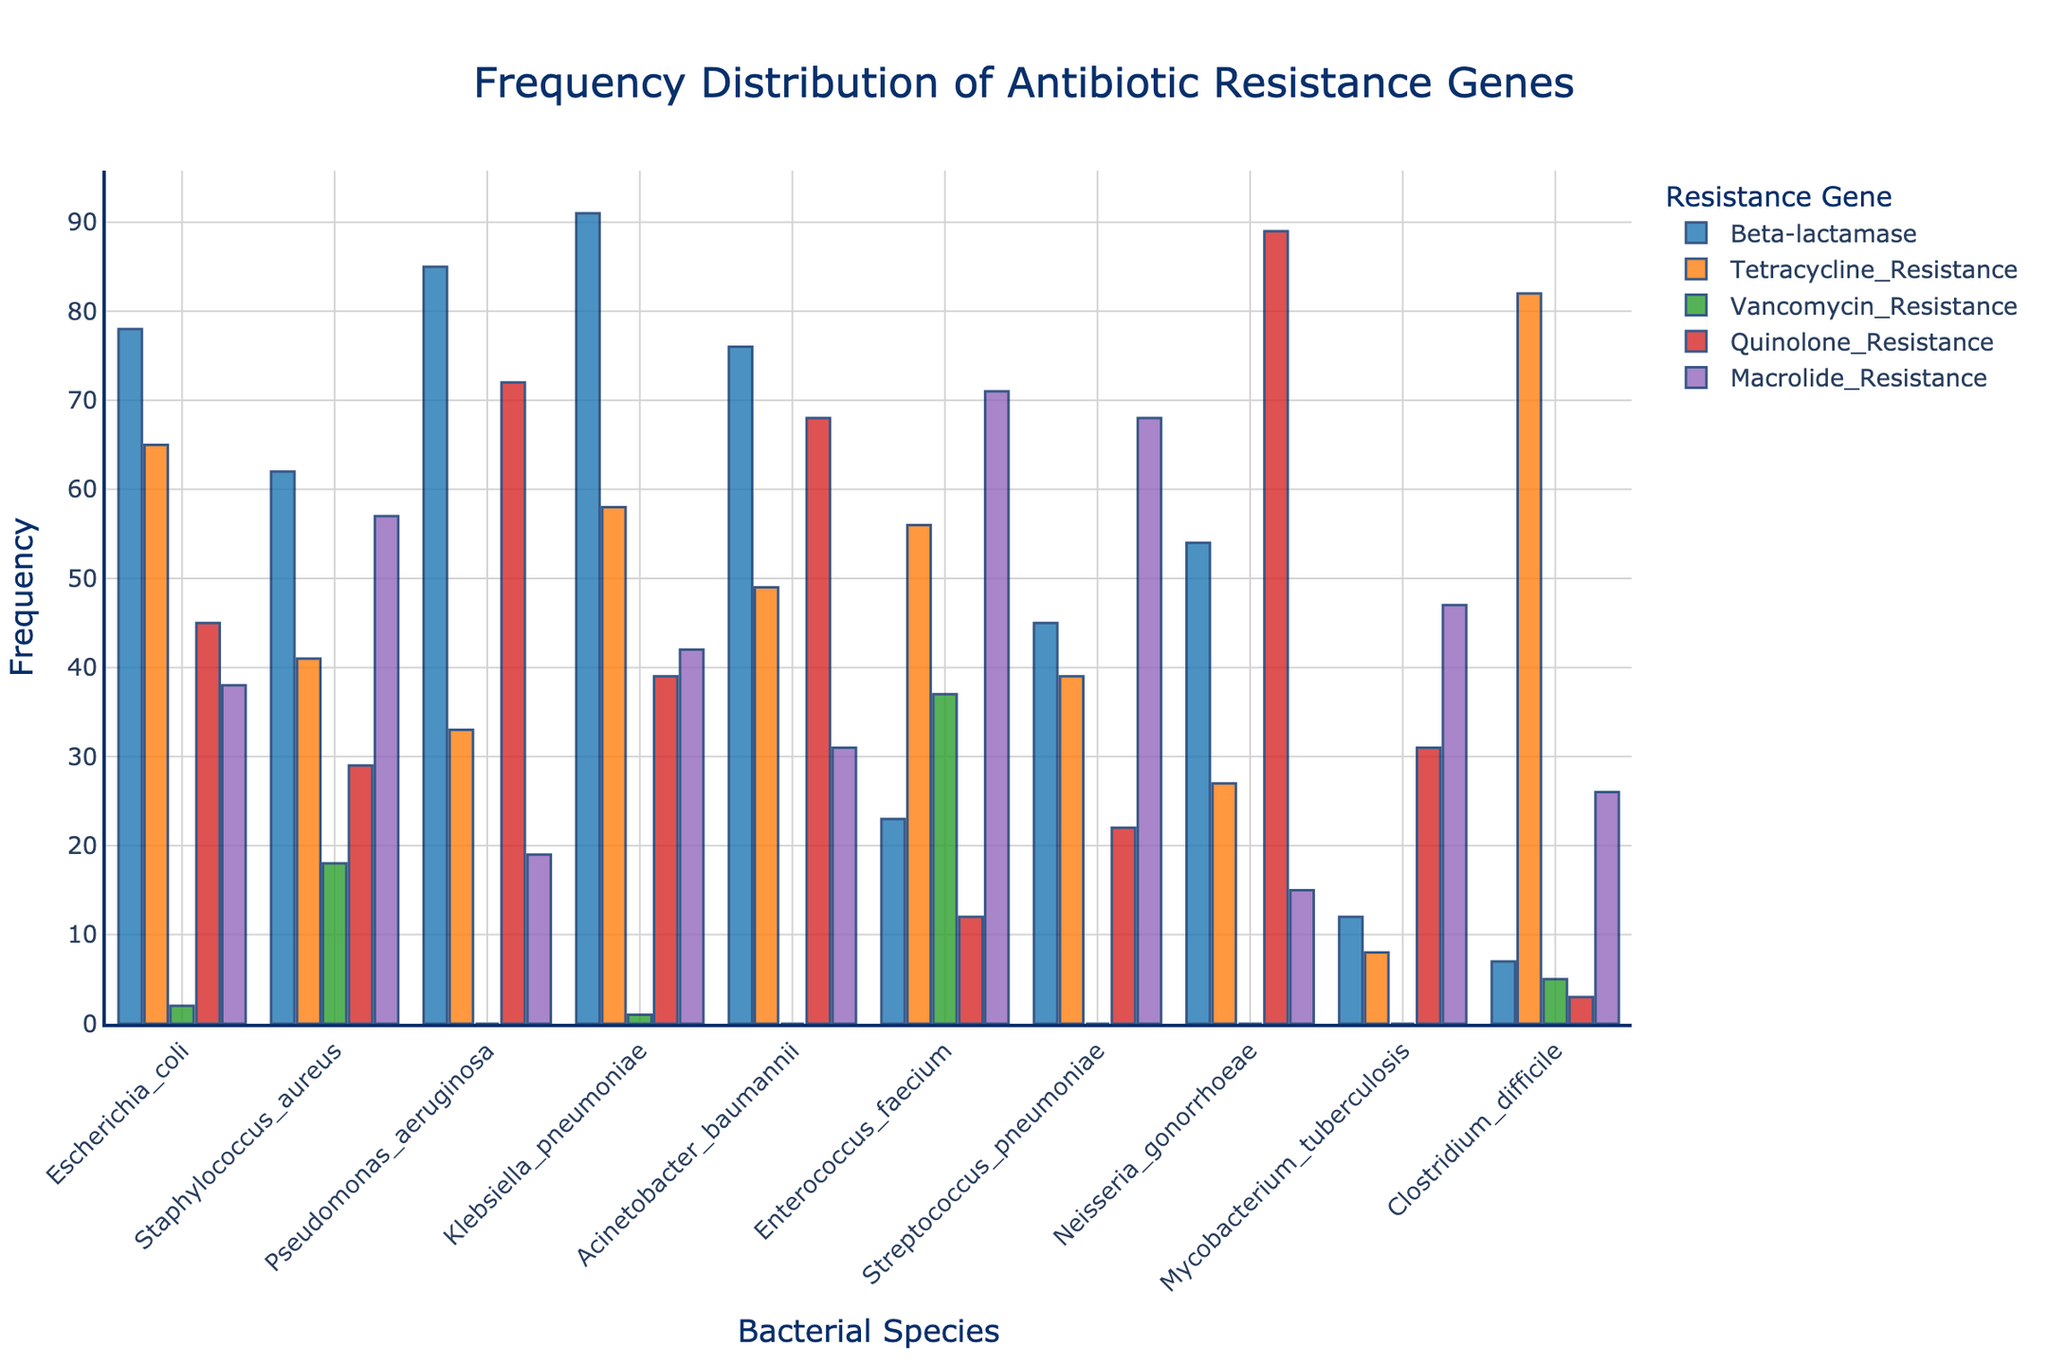Which bacterial species has the highest frequency of Beta-lactamase genes? The bar representing Beta-lactamase genes for each bacterial species should be examined, and the one with the highest length identifies the species. Klebsiella pneumoniae has the highest bar for Beta-lactamase with a frequency of 91.
Answer: Klebsiella pneumoniae Which resistance gene shows the lowest frequency in Mycobacterium tuberculosis? Look at the height of each bar labeled for Mycobacterium tuberculosis and find the shortest one. The shortest bar is Vancomycin_Resistance with a frequency of 0.
Answer: Vancomycin_Resistance What is the average frequency of Tetracycline_Resistance across all bacterial species? Find the frequencies for Tetracycline_Resistance and calculate their average: (65 + 41 + 33 + 58 + 49 + 56 + 39 + 27 + 8 + 82) / 10. The sum is 458, and the average is 458 / 10 = 45.8.
Answer: 45.8 How does the frequency of Quinolone_Resistance in Neisseria gonorrhoeae compare with that in Enterococcus faecium? Compare the heights of the Quinolone_Resistance bars for Neisseria gonorrhoeae and Enterococcus faecium. Neisseria gonorrhoeae has a height of 89 and Enterococcus faecium has a height of 12; thus, Neisseria gonorrhoeae has a significantly higher frequency.
Answer: Neisseria gonorrhoeae Which bacterial species has almost identical frequencies of Macrolide_Resistance and Tetracycline_Resistance? Compare the heights of the Macrolide_Resistance and Tetracycline_Resistance bars and look for nearly matching lengths. Streptococcus pneumoniae has Macrolide_Resistance at 68 and Tetracycline_Resistance at 39, which are closer in comparison to others.
Answer: Streptococcus pneumoniae How does the frequency of Vancomycin_Resistance in Clostridium difficile compare to that in Staphylococcus aureus? Compare the heights of Vancomycin_Resistance bars for Clostridium difficile and Staphylococcus aureus. Clostridium difficile has a frequency of 5, while Staphylococcus aureus has 18, so Staphylococcus aureus is higher.
Answer: Staphylococcus aureus Calculate the total frequency of Beta-lactamase genes across all bacterial species. Summing up the frequencies for Beta-lactamase in all species: 78 (Escherichia coli) + 62 (Staphylococcus aureus) + 85 (Pseudomonas aeruginosa) + 91 (Klebsiella pneumoniae) + 76 (Acinetobacter baumannii) + 23 (Enterococcus faecium) + 45 (Streptococcus pneumoniae) + 54 (Neisseria gonorrhoeae) + 12 (Mycobacterium tuberculosis) + 7 (Clostridium difficile) = 533.
Answer: 533 Is there any bacterial species that shows resistance to all five antibiotic classes? Check bars for each bacterial species across all five resistance categories (Beta-lactamase, Tetracycline_Resistance, Vancomycin_Resistance, Quinolone_Resistance, Macrolide_Resistance). All species show some resistance in most, but not all.
Answer: No Which resistance gene has the most consistent frequency across all bacterial species? Examine the bars of each resistance gene and look for relatively uniform heights. Macrolide_Resistance appears to be the most consistent with frequencies ranging between 15 and 71.
Answer: Macrolide_Resistance 